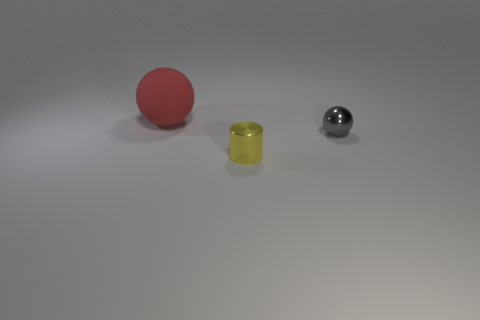What is the object in front of the small metal ball made of?
Your response must be concise. Metal. What is the material of the cylinder?
Your answer should be very brief. Metal. What is the thing to the left of the metal object in front of the sphere that is in front of the rubber object made of?
Your answer should be very brief. Rubber. Is there anything else that has the same material as the large red thing?
Provide a short and direct response. No. There is a metal cylinder; is it the same size as the ball in front of the big red ball?
Your response must be concise. Yes. What number of things are balls that are right of the red thing or things that are on the left side of the tiny ball?
Keep it short and to the point. 3. The tiny shiny object in front of the small gray sphere is what color?
Provide a short and direct response. Yellow. Is there a tiny sphere that is behind the sphere in front of the large red rubber object?
Provide a short and direct response. No. Are there fewer large matte objects than large shiny cylinders?
Offer a very short reply. No. What material is the sphere to the right of the tiny metallic thing that is left of the gray object?
Make the answer very short. Metal. 